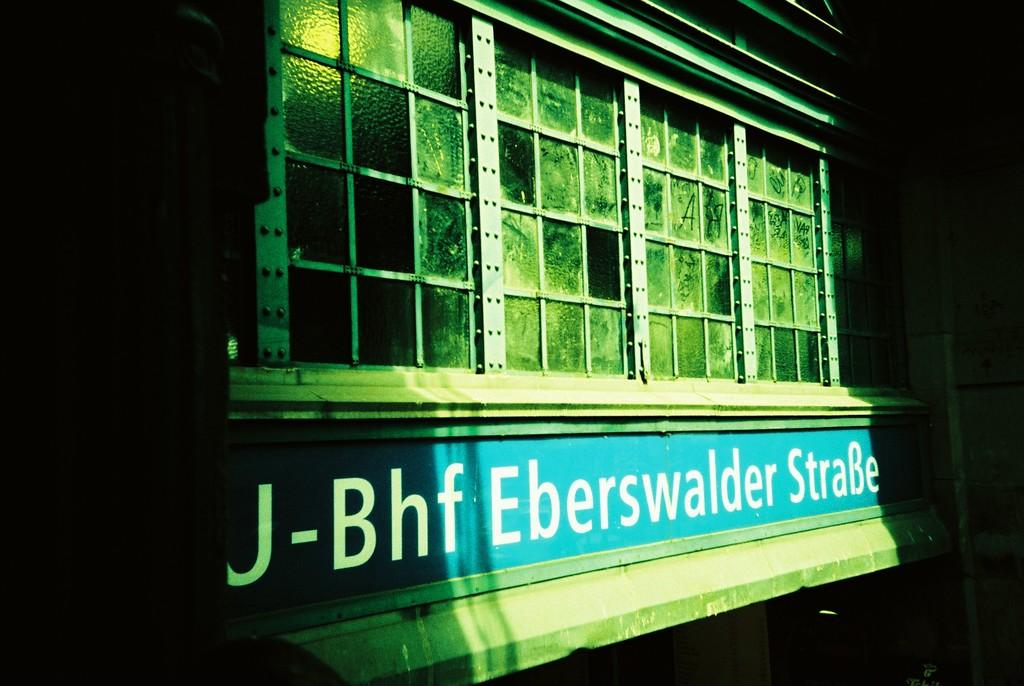What type of structure is present in the image? There is a building in the image. What feature can be observed on the building? The building has glass elements. Is there any signage on the building? Yes, there is a name board with a name on the building. Is there any illumination on the building? Yes, there is a light on the building. What type of food is being prepared in the building? There is no indication of food preparation in the image; it only shows a building with glass elements, a name board, and a light. 